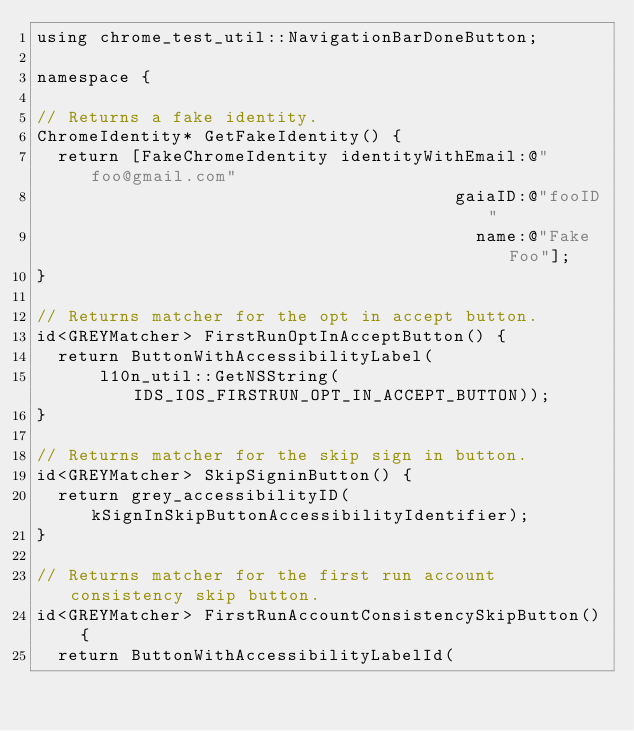<code> <loc_0><loc_0><loc_500><loc_500><_ObjectiveC_>using chrome_test_util::NavigationBarDoneButton;

namespace {

// Returns a fake identity.
ChromeIdentity* GetFakeIdentity() {
  return [FakeChromeIdentity identityWithEmail:@"foo@gmail.com"
                                        gaiaID:@"fooID"
                                          name:@"Fake Foo"];
}

// Returns matcher for the opt in accept button.
id<GREYMatcher> FirstRunOptInAcceptButton() {
  return ButtonWithAccessibilityLabel(
      l10n_util::GetNSString(IDS_IOS_FIRSTRUN_OPT_IN_ACCEPT_BUTTON));
}

// Returns matcher for the skip sign in button.
id<GREYMatcher> SkipSigninButton() {
  return grey_accessibilityID(kSignInSkipButtonAccessibilityIdentifier);
}

// Returns matcher for the first run account consistency skip button.
id<GREYMatcher> FirstRunAccountConsistencySkipButton() {
  return ButtonWithAccessibilityLabelId(</code> 